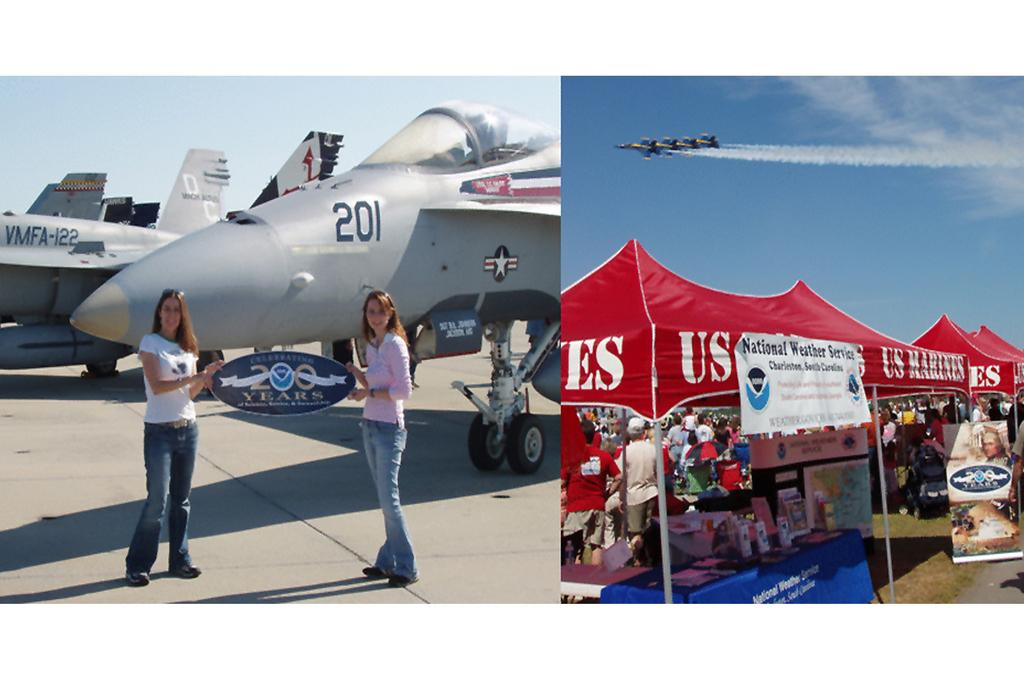<image>
Describe the image concisely. The large plane behind the to girls is numbered 201. 